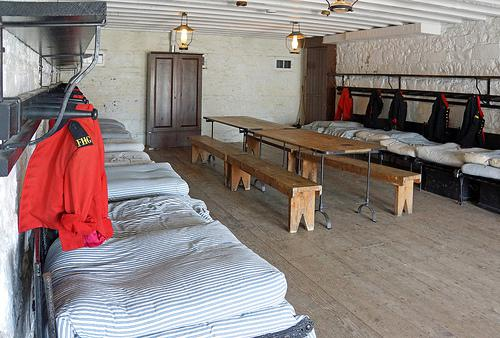Question: what color are the mattresses?
Choices:
A. Blue and white.
B. Black.
C. Grey.
D. Yellow.
Answer with the letter. Answer: A Question: what are the benches made of?
Choices:
A. Plastic.
B. Metal.
C. Cement.
D. Wood.
Answer with the letter. Answer: D 